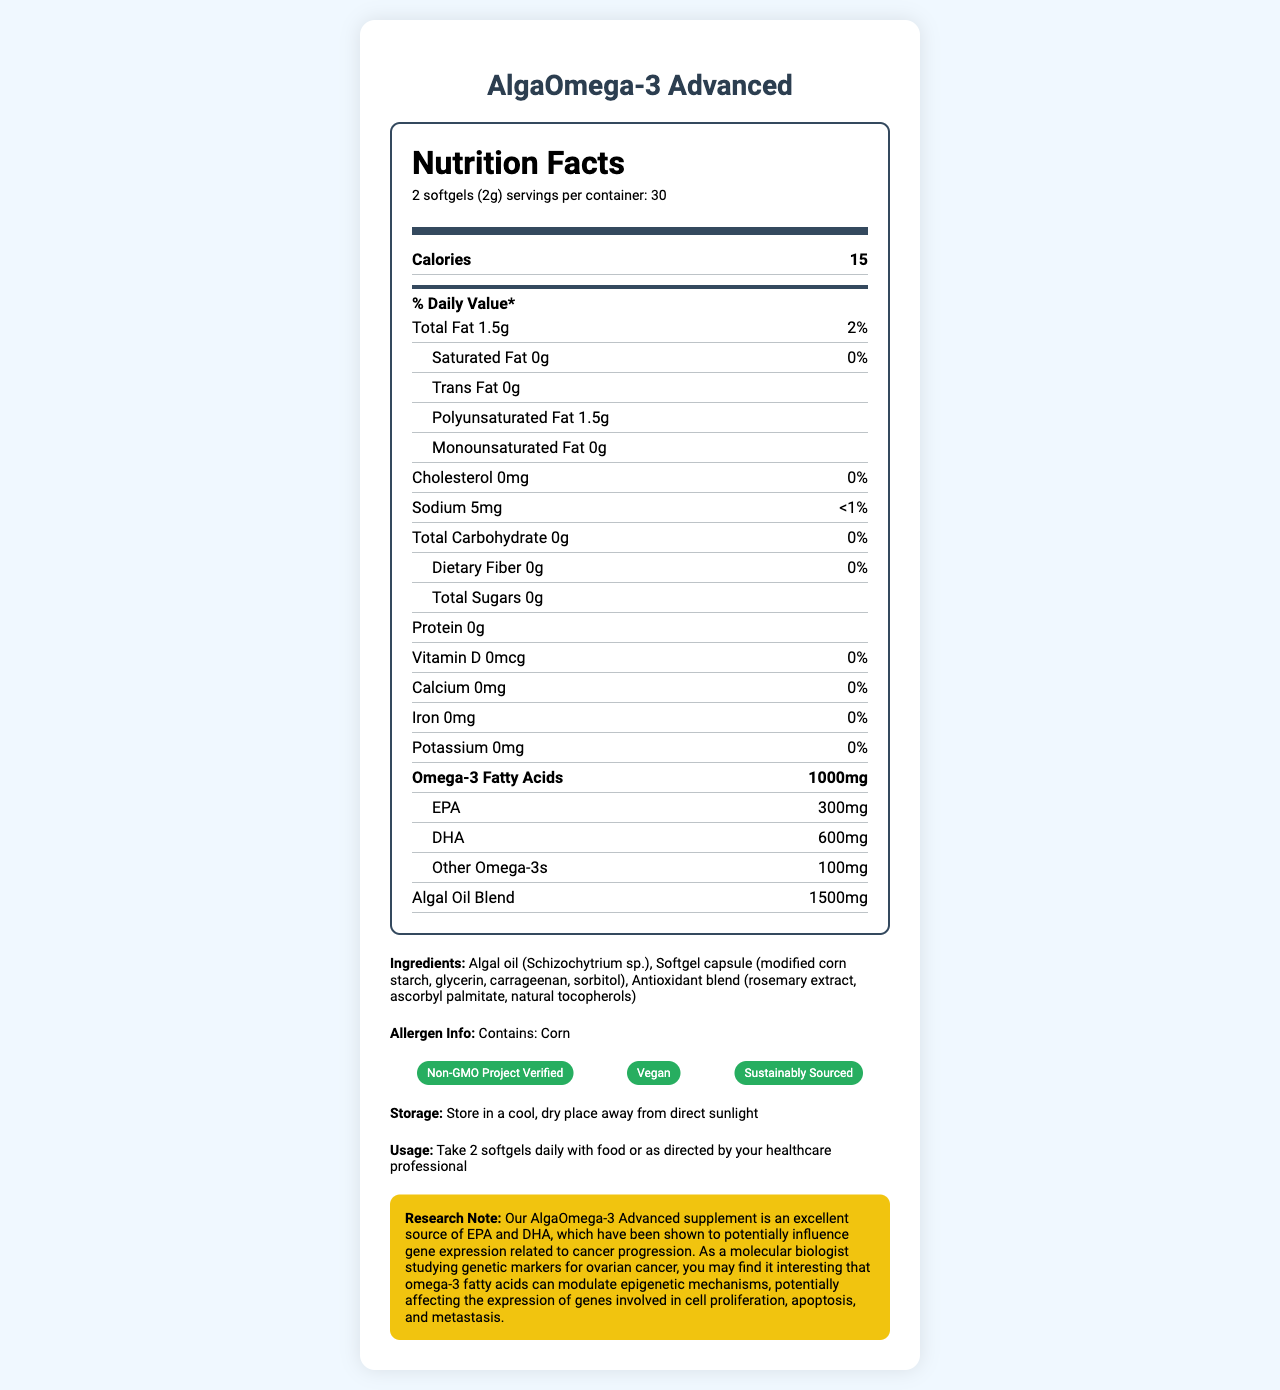what is the serving size? The serving size is listed as "2 softgels (2g)" at the top of the nutrition label.
Answer: 2 softgels (2g) how many calories are in one serving? The calories per serving are listed as 15 on the label.
Answer: 15 what is the total amount of Omega-3 fatty acids per serving? The total Omega-3 fatty acids per serving is explicitly mentioned as 1000mg.
Answer: 1000mg what percentage of the daily value is provided by the total fat content? The total fat content per serving is 1.5g, and it provides 2% of the daily value.
Answer: 2% are there any sugars in the supplement? The label indicates that the total sugars are 0g.
Answer: No how much sodium does this supplement contain? The sodium content per serving is 5mg.
Answer: 5mg what are the main ingredients in the supplement? The main ingredients are listed under the "Ingredients" section.
Answer: Algal oil (Schizochytrium sp.), Softgel capsule (modified corn starch, glycerin, carrageenan, sorbitol), Antioxidant blend (rosemary extract, ascorbyl palmitate, natural tocopherols) what certifications does the product have? The certifications are listed as Non-GMO Project Verified, Vegan, and Sustainably Sourced.
Answer: Non-GMO Project Verified, Vegan, Sustainably Sourced which types of omega-3 fatty acids are included, and in what amounts? A. EPA - 300mg, DHA - 600mg, Other - 100mg B. EPA - 500mg, DHA - 300mg, Other - 200mg C. EPA - 300mg, DHA - 500mg, Other - 200mg The label states that the supplement contains EPA - 300mg, DHA - 600mg, and Other Omega-3s - 100mg.
Answer: A how is the product supposed to be stored? A. In the refrigerator B. In a cool, dry place away from direct sunlight C. At room temperature The storage instructions specify to store in a cool, dry place away from direct sunlight.
Answer: B does the product contain any cholesterol? The label shows the cholesterol amount as 0mg.
Answer: No is the supplement free of allergens? The allergen information states that it contains corn.
Answer: No how many servings are there per container? The label indicates there are 30 servings per container.
Answer: 30 how much saturated fat is present per serving? The saturated fat content per serving is noted as 0g.
Answer: 0g what is the protein content per serving? The label shows the protein content as 0g per serving.
Answer: 0g describe the main features of the product. This explanation consolidates the key features and nutritional information of the product, giving an overview based on the label.
Answer: The AlgaOmega-3 Advanced supplement is a vegan, non-GMO, sustainably sourced omega-3 supplement derived from algae. It contains 1500mg of algal oil blend per serving, providing 1000mg of omega-3 fatty acids, including 300mg of EPA, 600mg of DHA, and 100mg of other omega-3s. The product is free of saturated fat, trans fat, cholesterol, sugars, protein, vitamin D, calcium, iron, and potassium. It should be stored in a cool, dry place away from direct sunlight and taken as 2 softgels daily with food or as directed by a healthcare professional. what gene expression related to cancer could omega-3 fatty acids influence? The label includes a research note stating that omega-3 fatty acids can modulate gene expression related to cell proliferation, apoptosis, and metastasis, potentially influencing cancer progression. However, the specific genes related to ovarian cancer cannot be determined from the label alone.
Answer: Cannot be determined 